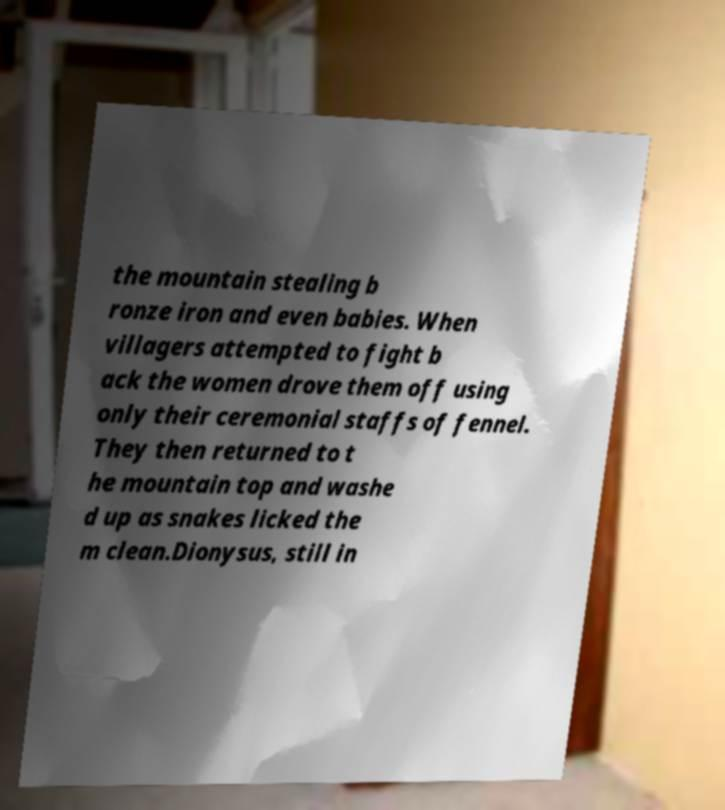Can you read and provide the text displayed in the image?This photo seems to have some interesting text. Can you extract and type it out for me? the mountain stealing b ronze iron and even babies. When villagers attempted to fight b ack the women drove them off using only their ceremonial staffs of fennel. They then returned to t he mountain top and washe d up as snakes licked the m clean.Dionysus, still in 